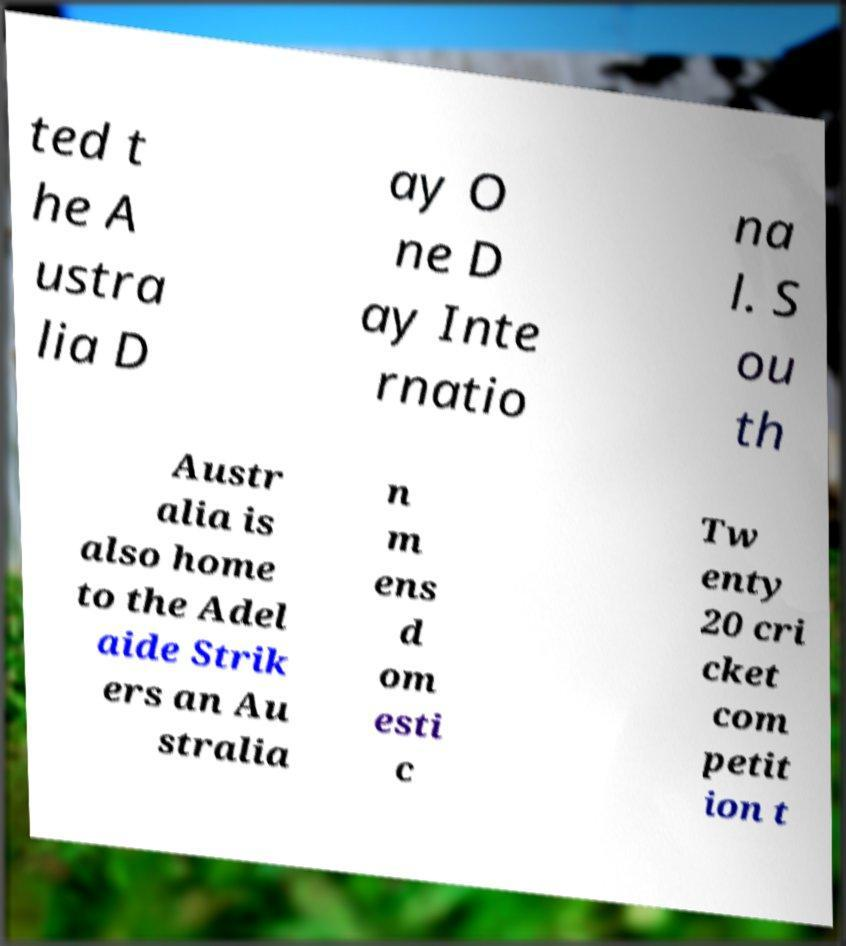Please identify and transcribe the text found in this image. ted t he A ustra lia D ay O ne D ay Inte rnatio na l. S ou th Austr alia is also home to the Adel aide Strik ers an Au stralia n m ens d om esti c Tw enty 20 cri cket com petit ion t 